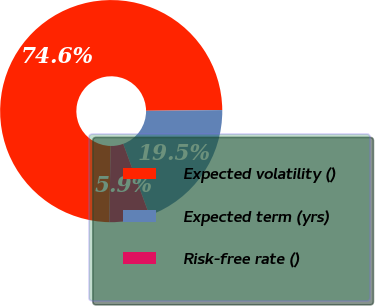<chart> <loc_0><loc_0><loc_500><loc_500><pie_chart><fcel>Expected volatility ()<fcel>Expected term (yrs)<fcel>Risk-free rate ()<nl><fcel>74.58%<fcel>19.55%<fcel>5.87%<nl></chart> 